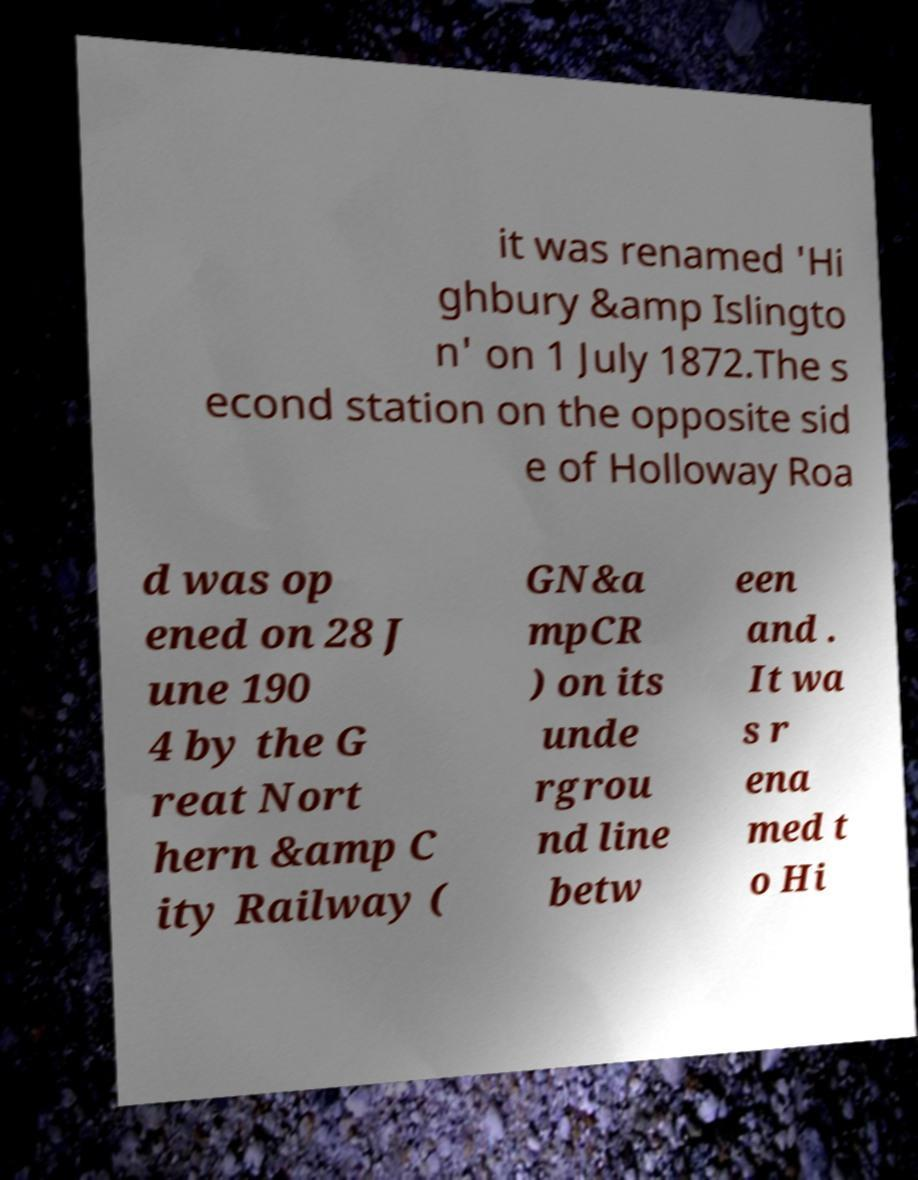Can you read and provide the text displayed in the image?This photo seems to have some interesting text. Can you extract and type it out for me? it was renamed 'Hi ghbury &amp Islingto n' on 1 July 1872.The s econd station on the opposite sid e of Holloway Roa d was op ened on 28 J une 190 4 by the G reat Nort hern &amp C ity Railway ( GN&a mpCR ) on its unde rgrou nd line betw een and . It wa s r ena med t o Hi 